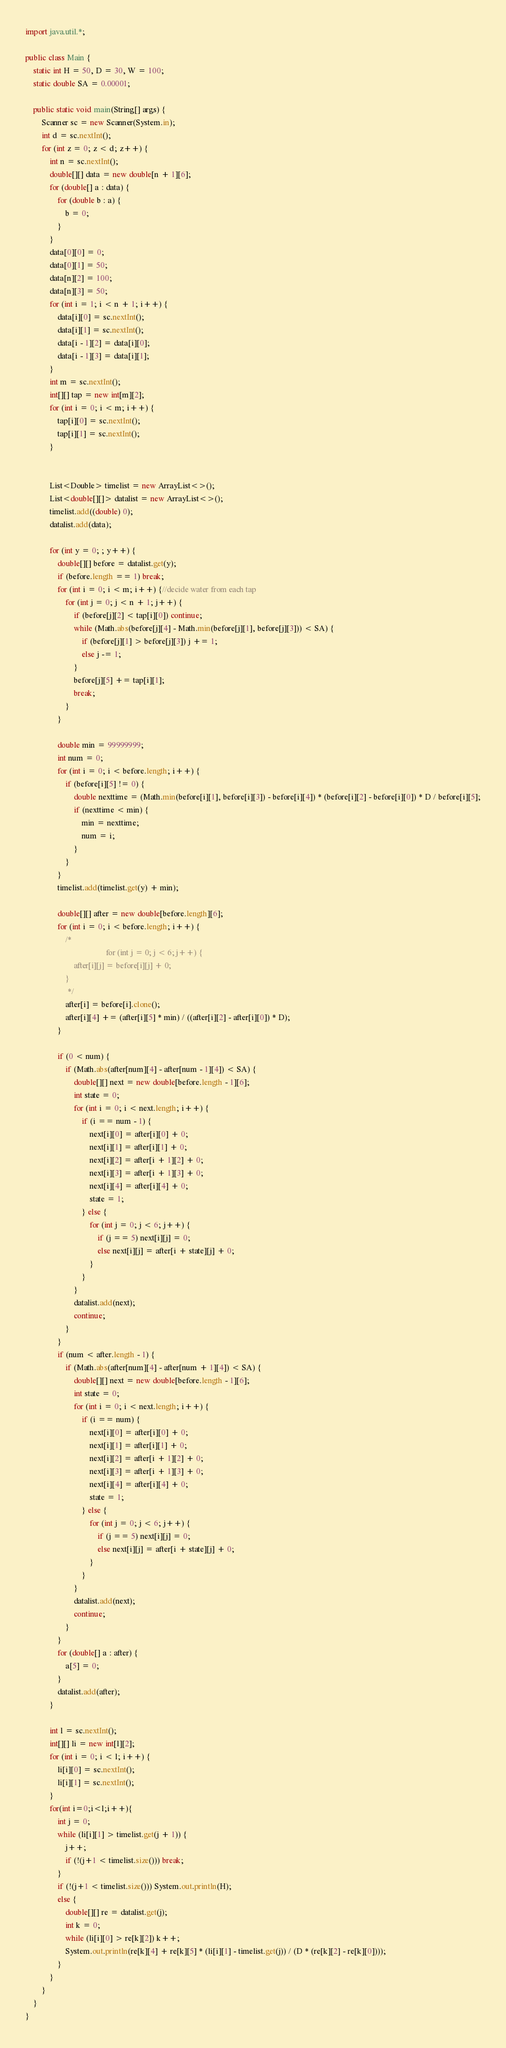<code> <loc_0><loc_0><loc_500><loc_500><_Java_>import java.util.*;

public class Main {
    static int H = 50, D = 30, W = 100;
    static double SA = 0.00001;

    public static void main(String[] args) {
        Scanner sc = new Scanner(System.in);
        int d = sc.nextInt();
        for (int z = 0; z < d; z++) {
            int n = sc.nextInt();
            double[][] data = new double[n + 1][6];
            for (double[] a : data) {
                for (double b : a) {
                    b = 0;
                }
            }
            data[0][0] = 0;
            data[0][1] = 50;
            data[n][2] = 100;
            data[n][3] = 50;
            for (int i = 1; i < n + 1; i++) {
                data[i][0] = sc.nextInt();
                data[i][1] = sc.nextInt();
                data[i - 1][2] = data[i][0];
                data[i - 1][3] = data[i][1];
            }
            int m = sc.nextInt();
            int[][] tap = new int[m][2];
            for (int i = 0; i < m; i++) {
                tap[i][0] = sc.nextInt();
                tap[i][1] = sc.nextInt();
            }


            List<Double> timelist = new ArrayList<>();
            List<double[][]> datalist = new ArrayList<>();
            timelist.add((double) 0);
            datalist.add(data);

            for (int y = 0; ; y++) {
                double[][] before = datalist.get(y);
                if (before.length == 1) break;
                for (int i = 0; i < m; i++) {//decide water from each tap
                    for (int j = 0; j < n + 1; j++) {
                        if (before[j][2] < tap[i][0]) continue;
                        while (Math.abs(before[j][4] - Math.min(before[j][1], before[j][3])) < SA) {
                            if (before[j][1] > before[j][3]) j += 1;
                            else j -= 1;
                        }
                        before[j][5] += tap[i][1];
                        break;
                    }
                }

                double min = 99999999;
                int num = 0;
                for (int i = 0; i < before.length; i++) {
                    if (before[i][5] != 0) {
                        double nexttime = (Math.min(before[i][1], before[i][3]) - before[i][4]) * (before[i][2] - before[i][0]) * D / before[i][5];
                        if (nexttime < min) {
                            min = nexttime;
                            num = i;
                        }
                    }
                }
                timelist.add(timelist.get(y) + min);

                double[][] after = new double[before.length][6];
                for (int i = 0; i < before.length; i++) {
                    /*
                                        for (int j = 0; j < 6; j++) {
                        after[i][j] = before[i][j] + 0;
                    }
                     */
                    after[i] = before[i].clone();
                    after[i][4] += (after[i][5] * min) / ((after[i][2] - after[i][0]) * D);
                }

                if (0 < num) {
                    if (Math.abs(after[num][4] - after[num - 1][4]) < SA) {
                        double[][] next = new double[before.length - 1][6];
                        int state = 0;
                        for (int i = 0; i < next.length; i++) {
                            if (i == num - 1) {
                                next[i][0] = after[i][0] + 0;
                                next[i][1] = after[i][1] + 0;
                                next[i][2] = after[i + 1][2] + 0;
                                next[i][3] = after[i + 1][3] + 0;
                                next[i][4] = after[i][4] + 0;
                                state = 1;
                            } else {
                                for (int j = 0; j < 6; j++) {
                                    if (j == 5) next[i][j] = 0;
                                    else next[i][j] = after[i + state][j] + 0;
                                }
                            }
                        }
                        datalist.add(next);
                        continue;
                    }
                }
                if (num < after.length - 1) {
                    if (Math.abs(after[num][4] - after[num + 1][4]) < SA) {
                        double[][] next = new double[before.length - 1][6];
                        int state = 0;
                        for (int i = 0; i < next.length; i++) {
                            if (i == num) {
                                next[i][0] = after[i][0] + 0;
                                next[i][1] = after[i][1] + 0;
                                next[i][2] = after[i + 1][2] + 0;
                                next[i][3] = after[i + 1][3] + 0;
                                next[i][4] = after[i][4] + 0;
                                state = 1;
                            } else {
                                for (int j = 0; j < 6; j++) {
                                    if (j == 5) next[i][j] = 0;
                                    else next[i][j] = after[i + state][j] + 0;
                                }
                            }
                        }
                        datalist.add(next);
                        continue;
                    }
                }
                for (double[] a : after) {
                    a[5] = 0;
                }
                datalist.add(after);
            }

            int l = sc.nextInt();
            int[][] li = new int[l][2];
            for (int i = 0; i < l; i++) {
                li[i][0] = sc.nextInt();
                li[i][1] = sc.nextInt();
            }
            for(int i=0;i<l;i++){
                int j = 0;
                while (li[i][1] > timelist.get(j + 1)) {
                    j++;
                    if (!(j+1 < timelist.size())) break;
                }
                if (!(j+1 < timelist.size())) System.out.println(H);
                else {
                    double[][] re = datalist.get(j);
                    int k = 0;
                    while (li[i][0] > re[k][2]) k++;
                    System.out.println(re[k][4] + re[k][5] * (li[i][1] - timelist.get(j)) / (D * (re[k][2] - re[k][0])));
                }
            }
        }
    }
}
</code> 